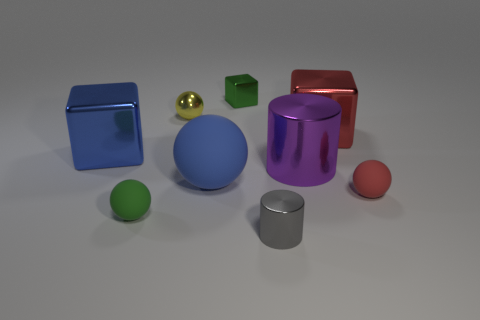Subtract 3 spheres. How many spheres are left? 1 Subtract all blue balls. How many balls are left? 3 Subtract all small green blocks. How many blocks are left? 2 Subtract 0 blue cylinders. How many objects are left? 9 Subtract all cylinders. How many objects are left? 7 Subtract all blue cylinders. Subtract all yellow balls. How many cylinders are left? 2 Subtract all brown blocks. How many red balls are left? 1 Subtract all red blocks. Subtract all tiny cubes. How many objects are left? 7 Add 5 small yellow spheres. How many small yellow spheres are left? 6 Add 5 small gray shiny things. How many small gray shiny things exist? 6 